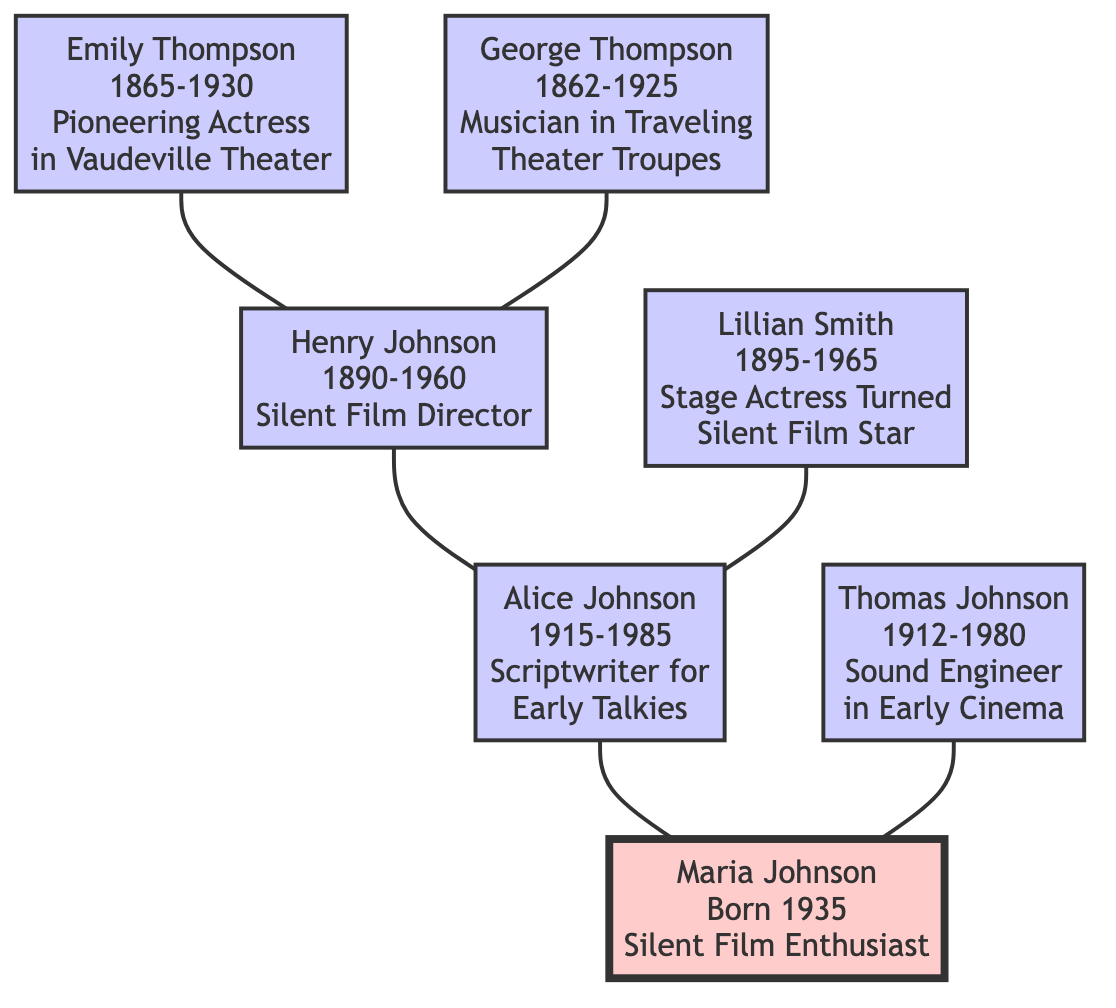What was Emily Thompson’s main contribution? Emily Thompson was recognized as a pioneering actress in Vaudeville theater, as stated in the node describing her.
Answer: Pioneering Actress in Vaudeville Theater Who is Maria Johnson's father? The diagram indicates that Thomas Johnson is connected as Maria Johnson's father, shown in the parent-child relationship in the tree.
Answer: Thomas Johnson How many ancestors are listed in the diagram? To find the number of ancestors, we count each individual connected to Maria Johnson who is her ancestor: Emily Thompson, George Thompson, Henry Johnson, Lillian Smith, Alice Johnson, and Thomas Johnson, totaling six.
Answer: 6 What type of filmmaker was Henry Johnson? The node for Henry Johnson specifies that he was a silent film director, giving his specific role in the performing arts.
Answer: Silent Film Director Which ancestor contributed to early talkies? The diagram highlights Alice Johnson's contribution specifically as a scriptwriter for early talkies, making her the ancestor associated with that contribution.
Answer: Alice Johnson What relationship does Lillian Smith have with Maria Johnson? In the diagram, Lillian Smith is shown as the grandmother of Maria Johnson, indicating their direct family relationship in the tree.
Answer: Grandmother List the years during which George Thompson lived. By examining the information in the diagram connected to George Thompson, we see he was born in 1862 and died in 1925.
Answer: 1862-1925 How is Maria Johnson connected to her great-grandparents? The diagram shows that Maria Johnson connects to her great-grandparents, Emily Thompson and George Thompson, through her grandparents, Henry Johnson and Lillian Smith, establishing her ancestral lineage.
Answer: Through her grandparents What was the occupation of Thomas Johnson? The diagram indicates that Thomas Johnson was a sound engineer in early cinema, thus defining his professional role.
Answer: Sound Engineer in Early Cinema 